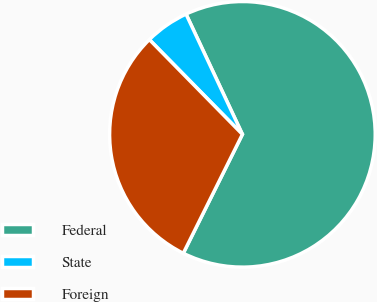Convert chart. <chart><loc_0><loc_0><loc_500><loc_500><pie_chart><fcel>Federal<fcel>State<fcel>Foreign<nl><fcel>64.32%<fcel>5.38%<fcel>30.3%<nl></chart> 